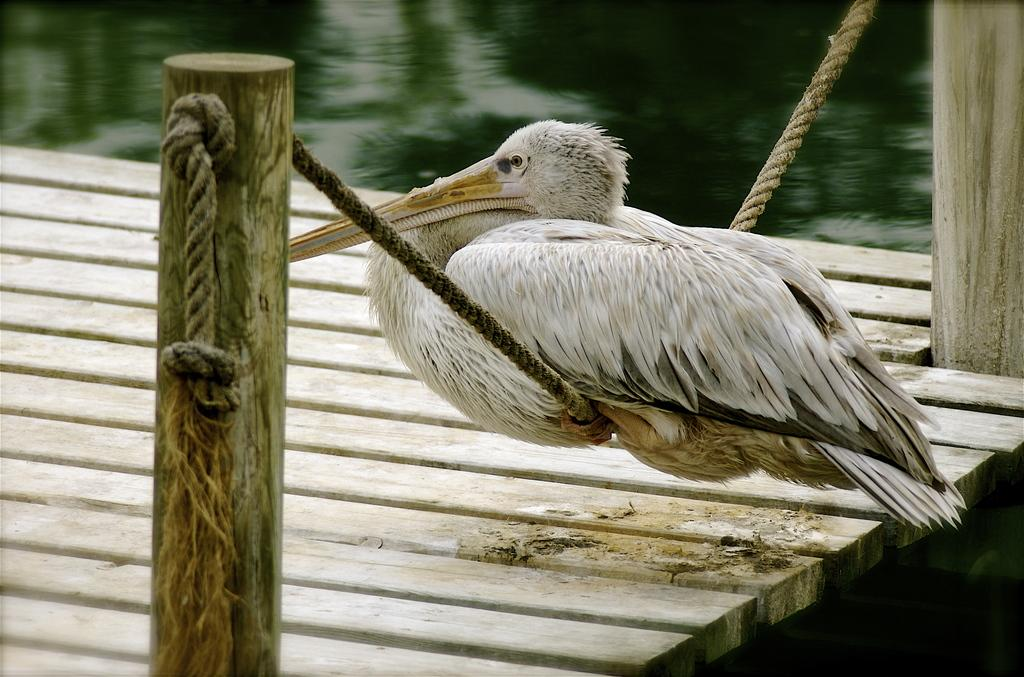What animal can be seen in the image? There is a duck in the image. How is the duck positioned in the image? The duck is on a rope. What type of structure is present in the image? There is a bridge in the image. What type of natural material can be seen in the image? There are logs visible in the image. What type of meal is being prepared on the logs in the image? There is no meal being prepared in the image; the logs are simply visible in the image. 